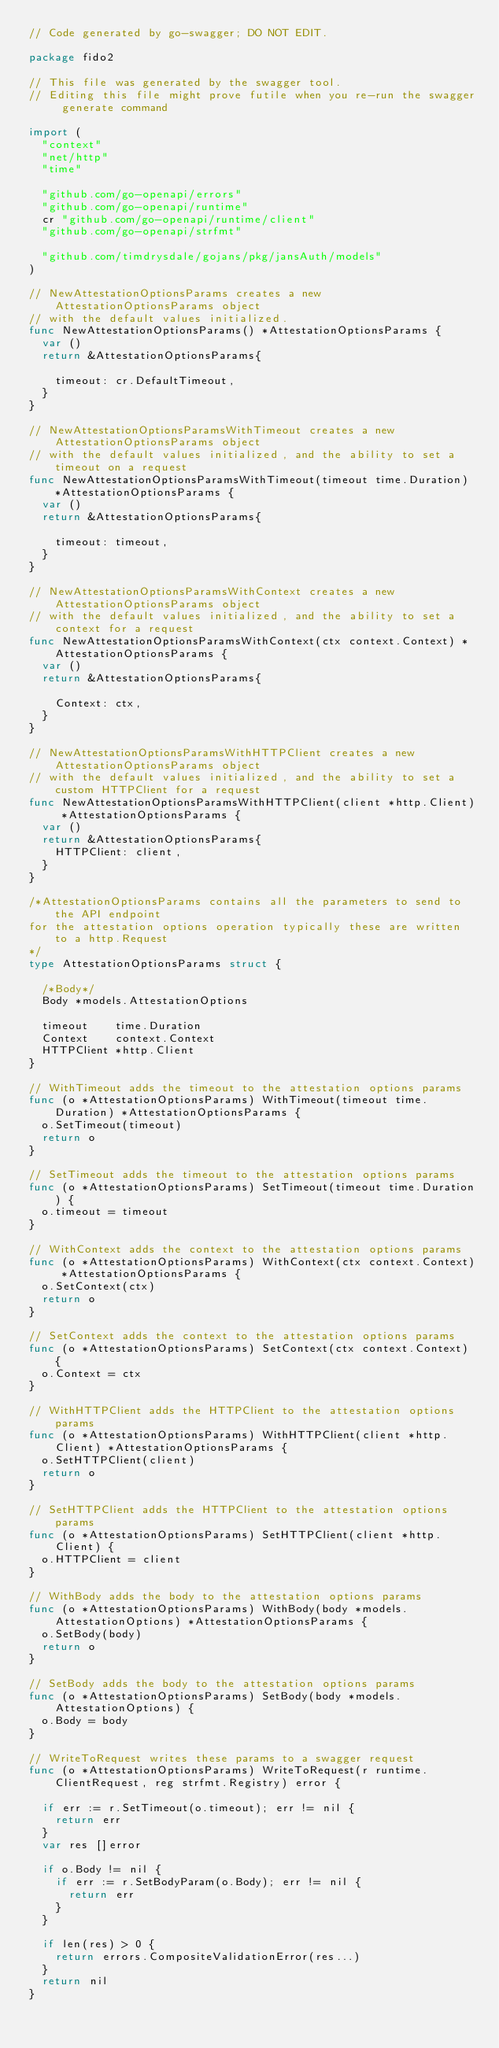<code> <loc_0><loc_0><loc_500><loc_500><_Go_>// Code generated by go-swagger; DO NOT EDIT.

package fido2

// This file was generated by the swagger tool.
// Editing this file might prove futile when you re-run the swagger generate command

import (
	"context"
	"net/http"
	"time"

	"github.com/go-openapi/errors"
	"github.com/go-openapi/runtime"
	cr "github.com/go-openapi/runtime/client"
	"github.com/go-openapi/strfmt"

	"github.com/timdrysdale/gojans/pkg/jansAuth/models"
)

// NewAttestationOptionsParams creates a new AttestationOptionsParams object
// with the default values initialized.
func NewAttestationOptionsParams() *AttestationOptionsParams {
	var ()
	return &AttestationOptionsParams{

		timeout: cr.DefaultTimeout,
	}
}

// NewAttestationOptionsParamsWithTimeout creates a new AttestationOptionsParams object
// with the default values initialized, and the ability to set a timeout on a request
func NewAttestationOptionsParamsWithTimeout(timeout time.Duration) *AttestationOptionsParams {
	var ()
	return &AttestationOptionsParams{

		timeout: timeout,
	}
}

// NewAttestationOptionsParamsWithContext creates a new AttestationOptionsParams object
// with the default values initialized, and the ability to set a context for a request
func NewAttestationOptionsParamsWithContext(ctx context.Context) *AttestationOptionsParams {
	var ()
	return &AttestationOptionsParams{

		Context: ctx,
	}
}

// NewAttestationOptionsParamsWithHTTPClient creates a new AttestationOptionsParams object
// with the default values initialized, and the ability to set a custom HTTPClient for a request
func NewAttestationOptionsParamsWithHTTPClient(client *http.Client) *AttestationOptionsParams {
	var ()
	return &AttestationOptionsParams{
		HTTPClient: client,
	}
}

/*AttestationOptionsParams contains all the parameters to send to the API endpoint
for the attestation options operation typically these are written to a http.Request
*/
type AttestationOptionsParams struct {

	/*Body*/
	Body *models.AttestationOptions

	timeout    time.Duration
	Context    context.Context
	HTTPClient *http.Client
}

// WithTimeout adds the timeout to the attestation options params
func (o *AttestationOptionsParams) WithTimeout(timeout time.Duration) *AttestationOptionsParams {
	o.SetTimeout(timeout)
	return o
}

// SetTimeout adds the timeout to the attestation options params
func (o *AttestationOptionsParams) SetTimeout(timeout time.Duration) {
	o.timeout = timeout
}

// WithContext adds the context to the attestation options params
func (o *AttestationOptionsParams) WithContext(ctx context.Context) *AttestationOptionsParams {
	o.SetContext(ctx)
	return o
}

// SetContext adds the context to the attestation options params
func (o *AttestationOptionsParams) SetContext(ctx context.Context) {
	o.Context = ctx
}

// WithHTTPClient adds the HTTPClient to the attestation options params
func (o *AttestationOptionsParams) WithHTTPClient(client *http.Client) *AttestationOptionsParams {
	o.SetHTTPClient(client)
	return o
}

// SetHTTPClient adds the HTTPClient to the attestation options params
func (o *AttestationOptionsParams) SetHTTPClient(client *http.Client) {
	o.HTTPClient = client
}

// WithBody adds the body to the attestation options params
func (o *AttestationOptionsParams) WithBody(body *models.AttestationOptions) *AttestationOptionsParams {
	o.SetBody(body)
	return o
}

// SetBody adds the body to the attestation options params
func (o *AttestationOptionsParams) SetBody(body *models.AttestationOptions) {
	o.Body = body
}

// WriteToRequest writes these params to a swagger request
func (o *AttestationOptionsParams) WriteToRequest(r runtime.ClientRequest, reg strfmt.Registry) error {

	if err := r.SetTimeout(o.timeout); err != nil {
		return err
	}
	var res []error

	if o.Body != nil {
		if err := r.SetBodyParam(o.Body); err != nil {
			return err
		}
	}

	if len(res) > 0 {
		return errors.CompositeValidationError(res...)
	}
	return nil
}
</code> 